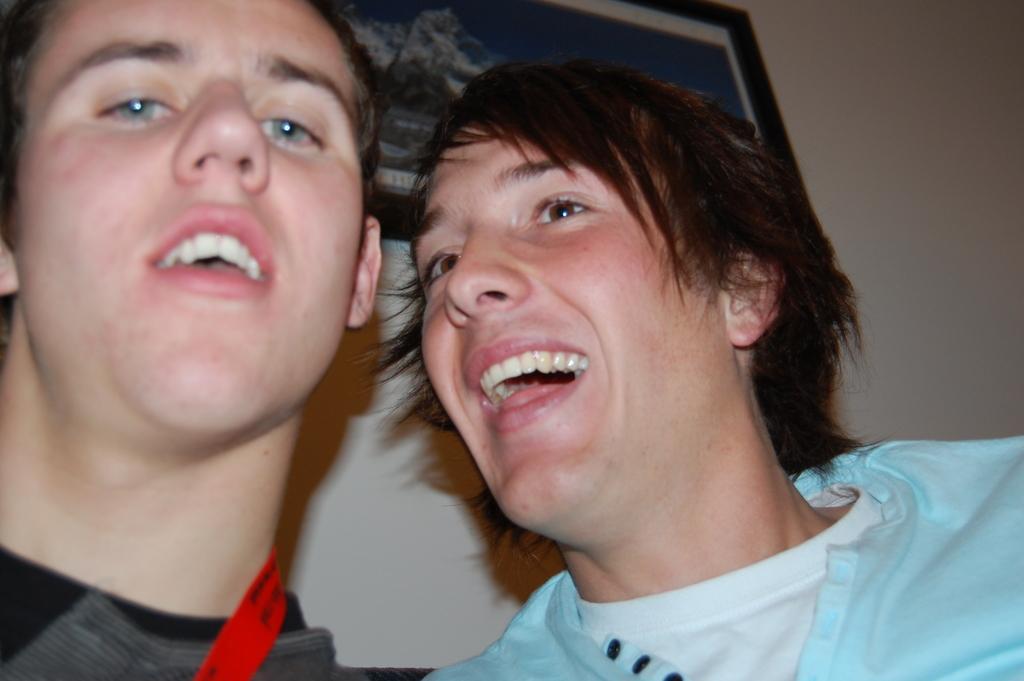Can you describe this image briefly? In the left side a man is looking at this side. In the right side this person is laughing. He wore a light blue color t-shirt behind them it's a frame on the wall. 